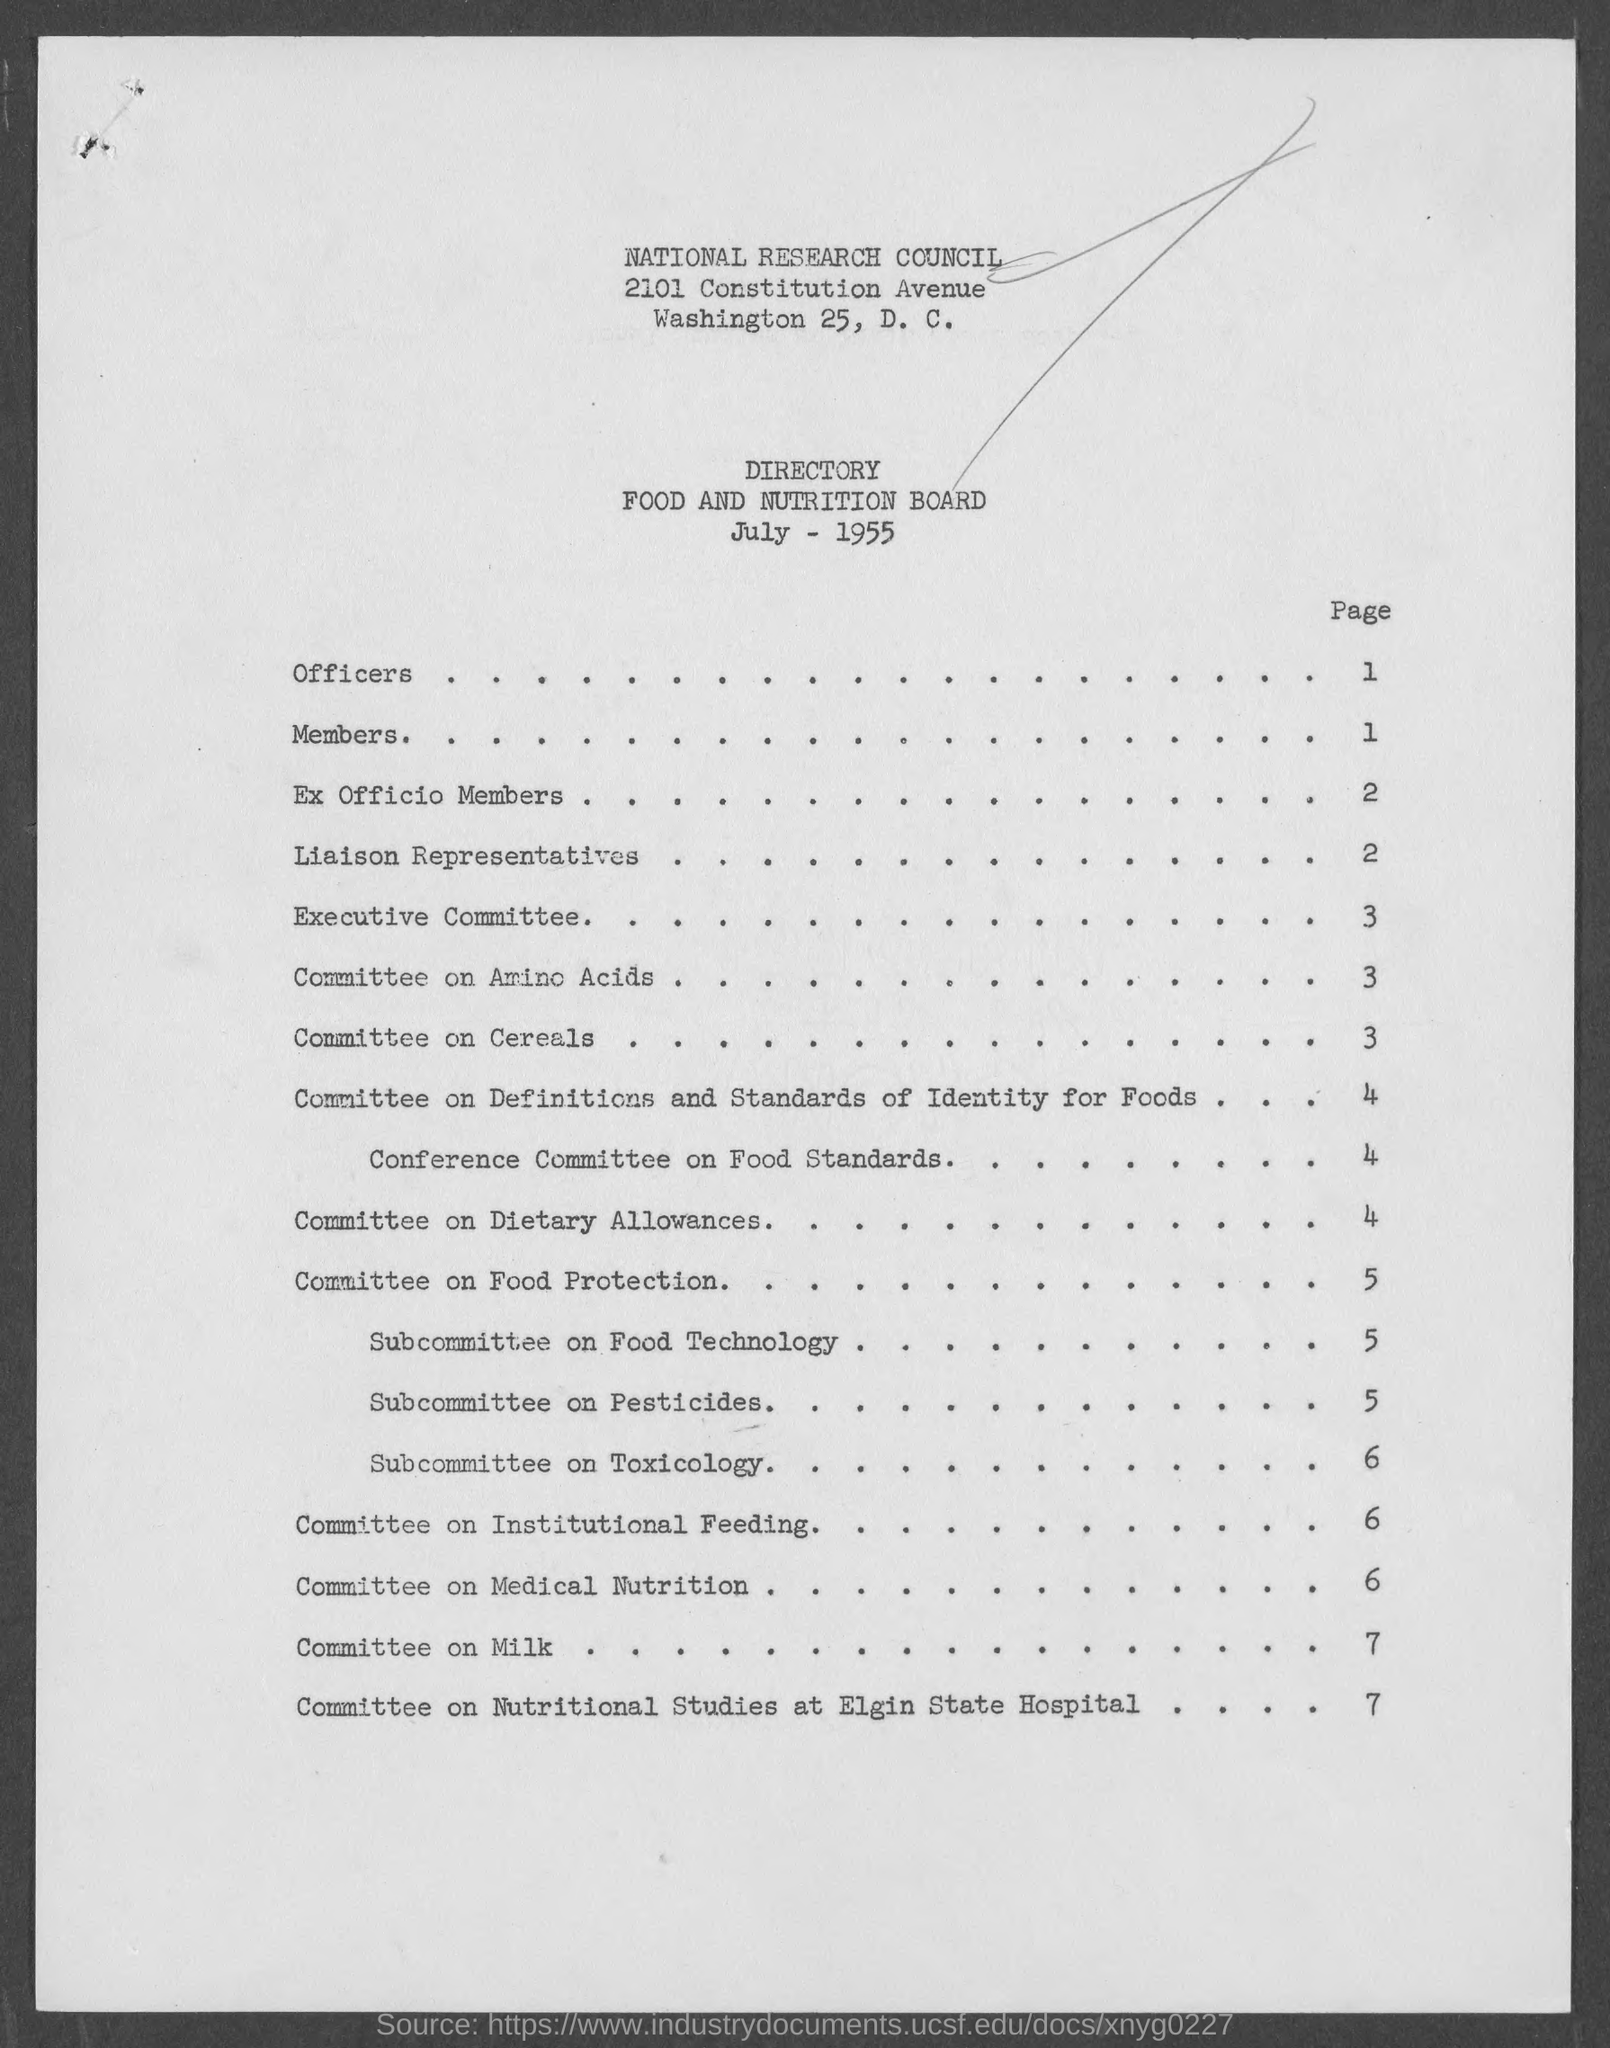Identify some key points in this picture. The specific page number where the "Committee on Amino Acids" is mentioned is 3. The page number where the word 'Members' appears is 1.. The page number on which the "Committee on Milk" is mentioned is 7. The page number for the Executive Committee is 3. 